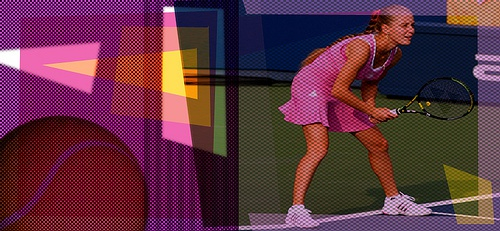Describe the objects in this image and their specific colors. I can see sports ball in black, maroon, and brown tones, people in black, maroon, brown, and salmon tones, tennis racket in black, darkgreen, and navy tones, and sports ball in black, olive, and maroon tones in this image. 